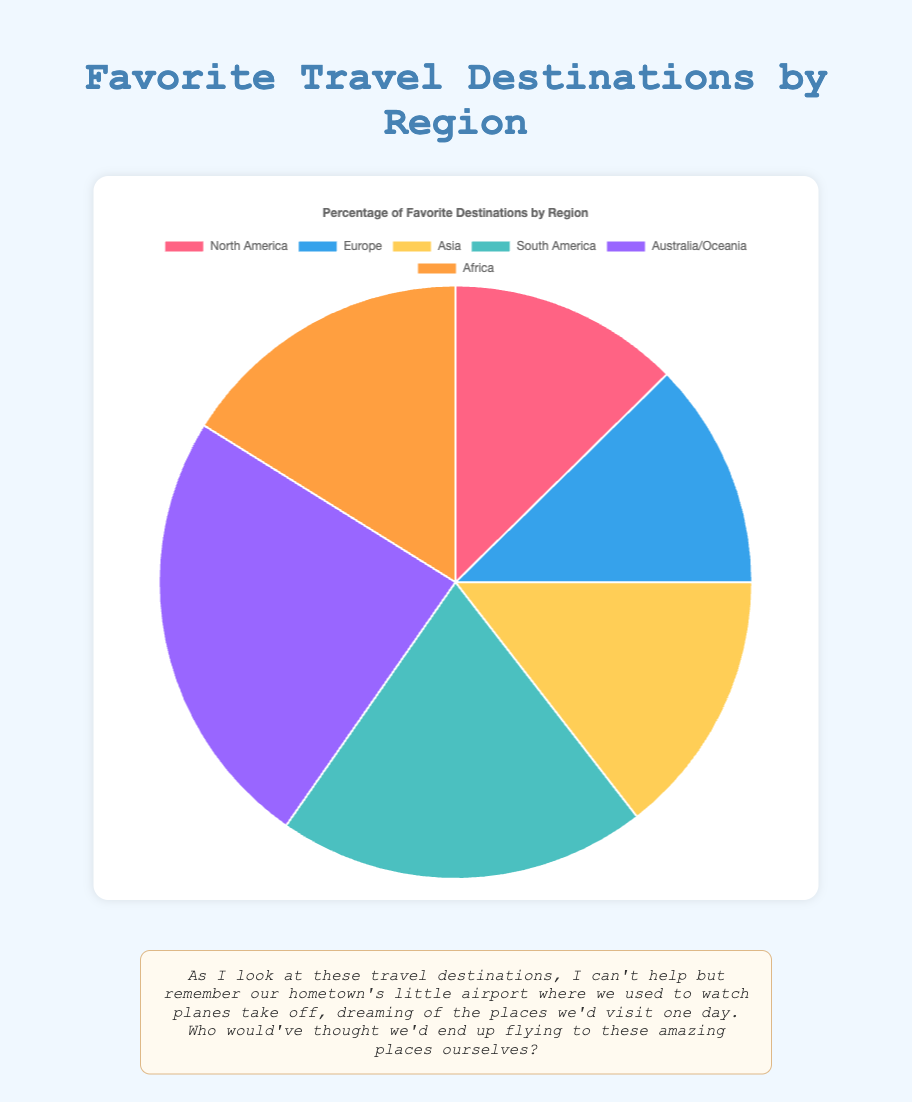What region has the highest percentage of favorite travel destinations? The slices of the pie chart show different regions with percentages. The largest slice corresponds to 'Australia/Oceania' with 90%.
Answer: Australia/Oceania Which region has the smallest percentage of favorite travel destinations? By visually inspecting the pie chart, the smallest slice belongs to 'North America' with 47%.
Answer: North America How much more percentage does Asia have compared to Europe? Asia has 54% and Europe has 46%. Subtracting the two gives 54% - 46% = 8%.
Answer: 8% What is the combined percentage of favorite travel destinations in North America and Europe? North America has 47% and Europe has 46%. Adding them together gives 47% + 46% = 93%.
Answer: 93% Which region has a percentage closest to 75%? Visually, the slice labeled 'South America' is closest to 75% as it holds that exact value.
Answer: South America What is the average percentage of favorite travel destinations for Africa and Asia? Africa has 60%, and Asia has 54%. The average is calculated as (60% + 54%) / 2 = 57%.
Answer: 57% Between Europe and Africa, which has a higher percentage and by how much? Europe has 46%, while Africa has 60%. The difference is calculated as 60% - 46% = 14%.
Answer: Africa by 14% Which region is represented by the light blue color, and what is its percentage? The light blue slice corresponds to 'Europe' with a percentage of 46%.
Answer: Europe, 46% How does the percentage of favorite destinations in Australia/Oceania compare against South America? Australia/Oceania has 90%, while South America has 75%. Australia/Oceania has a higher percentage by 15%.
Answer: Australia/Oceania by 15% What is the summed percentage of the regions colored in red and purple? The red-colored region is 'North America' with 47%, and the purple-colored region is 'Africa' with 60%. Summing these gives 47% + 60% = 107%.
Answer: 107% 